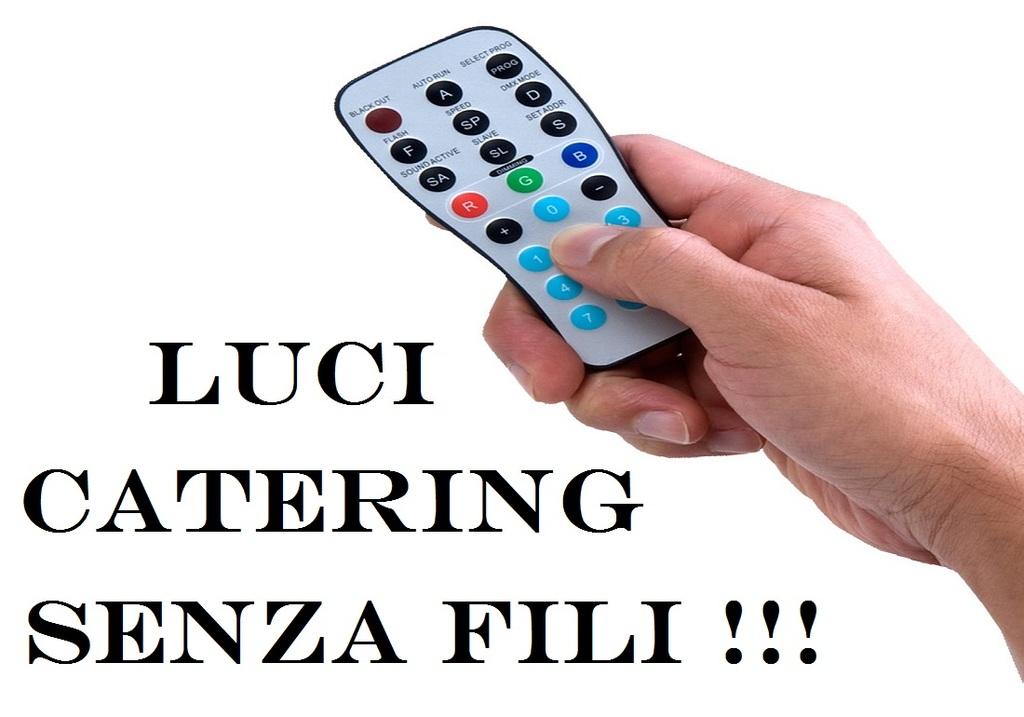What is the top button on the left of the remote for?
Provide a succinct answer. Black out. What letter is on the blue button?
Provide a short and direct response. B. 